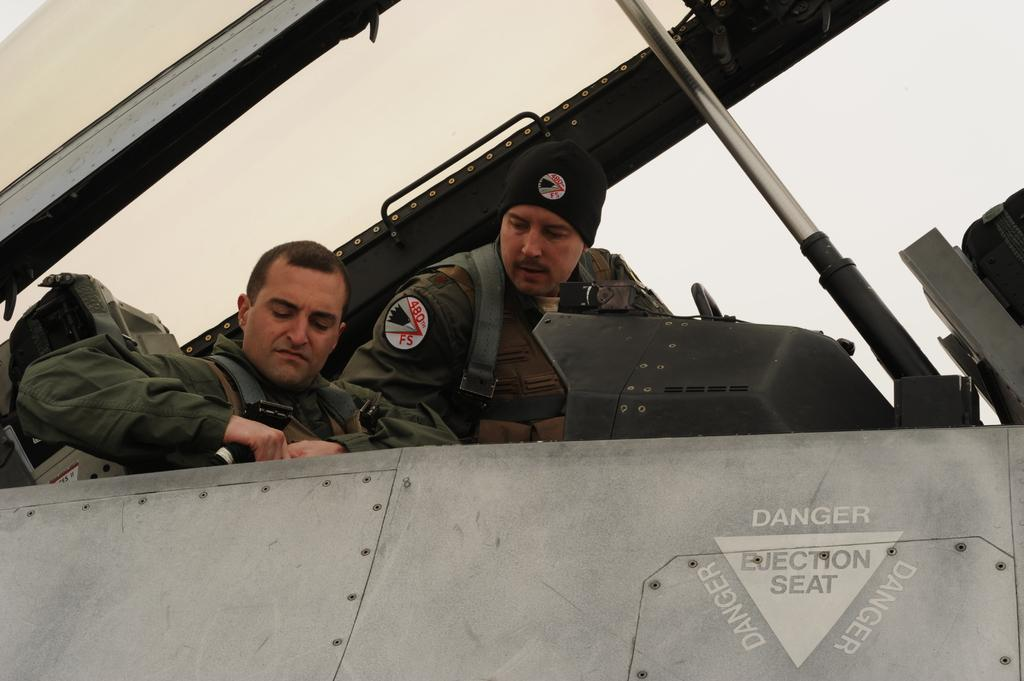How many people are in the image? There are two persons in the image. What are the two persons doing in the image? The two persons are sitting. What type of clothing are the two persons wearing? The two persons are wearing uniforms. What letters are the two persons holding in the image? There are no letters visible in the image. Who is the manager of the two persons in the image? There is no indication of a manager or any hierarchical relationship between the two persons in the image. 